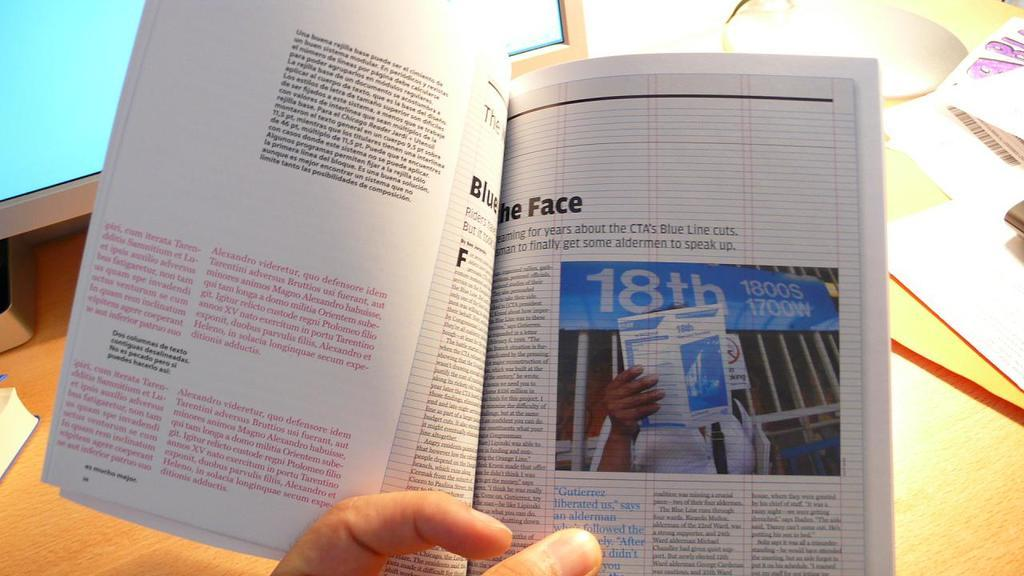What body parts are visible in the image? There are fingers visible in the image. What is the main object in the image? There is a book in the image. What can be seen in the background of the image? There is a monitor, a mouse, papers, and objects on a wooden platform in the background of the image. How many ducks are visible in the image? There are no ducks present in the image. What type of pain is being experienced by the person in the image? There is no indication of pain being experienced by anyone in the image. 